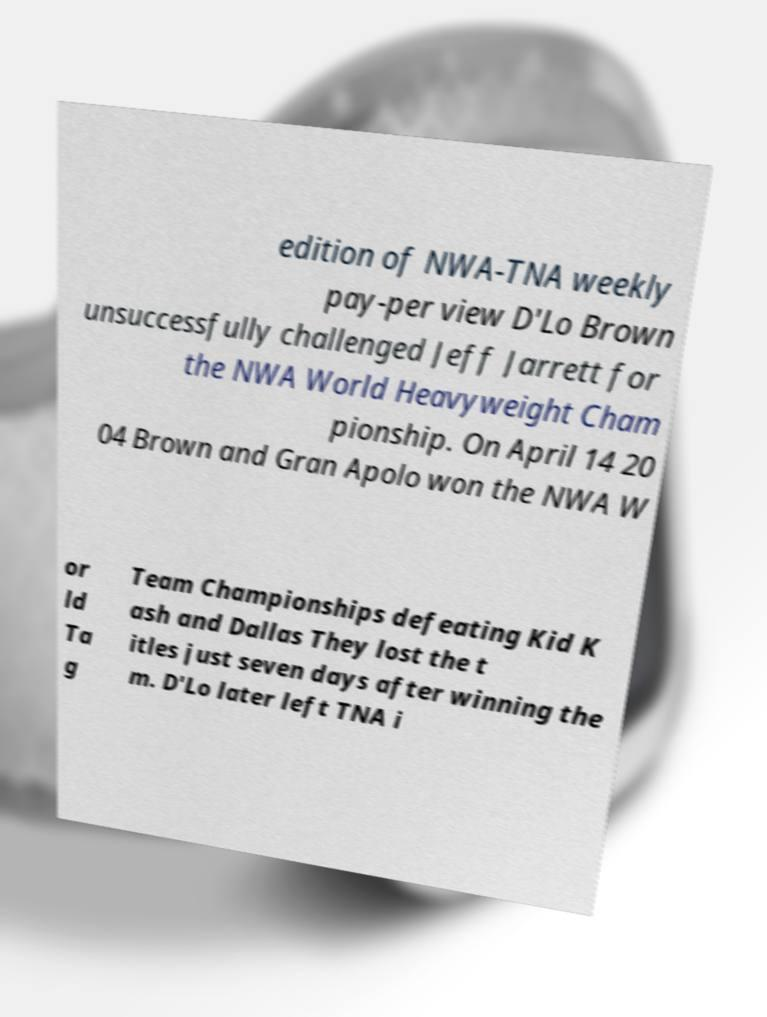For documentation purposes, I need the text within this image transcribed. Could you provide that? edition of NWA-TNA weekly pay-per view D'Lo Brown unsuccessfully challenged Jeff Jarrett for the NWA World Heavyweight Cham pionship. On April 14 20 04 Brown and Gran Apolo won the NWA W or ld Ta g Team Championships defeating Kid K ash and Dallas They lost the t itles just seven days after winning the m. D'Lo later left TNA i 